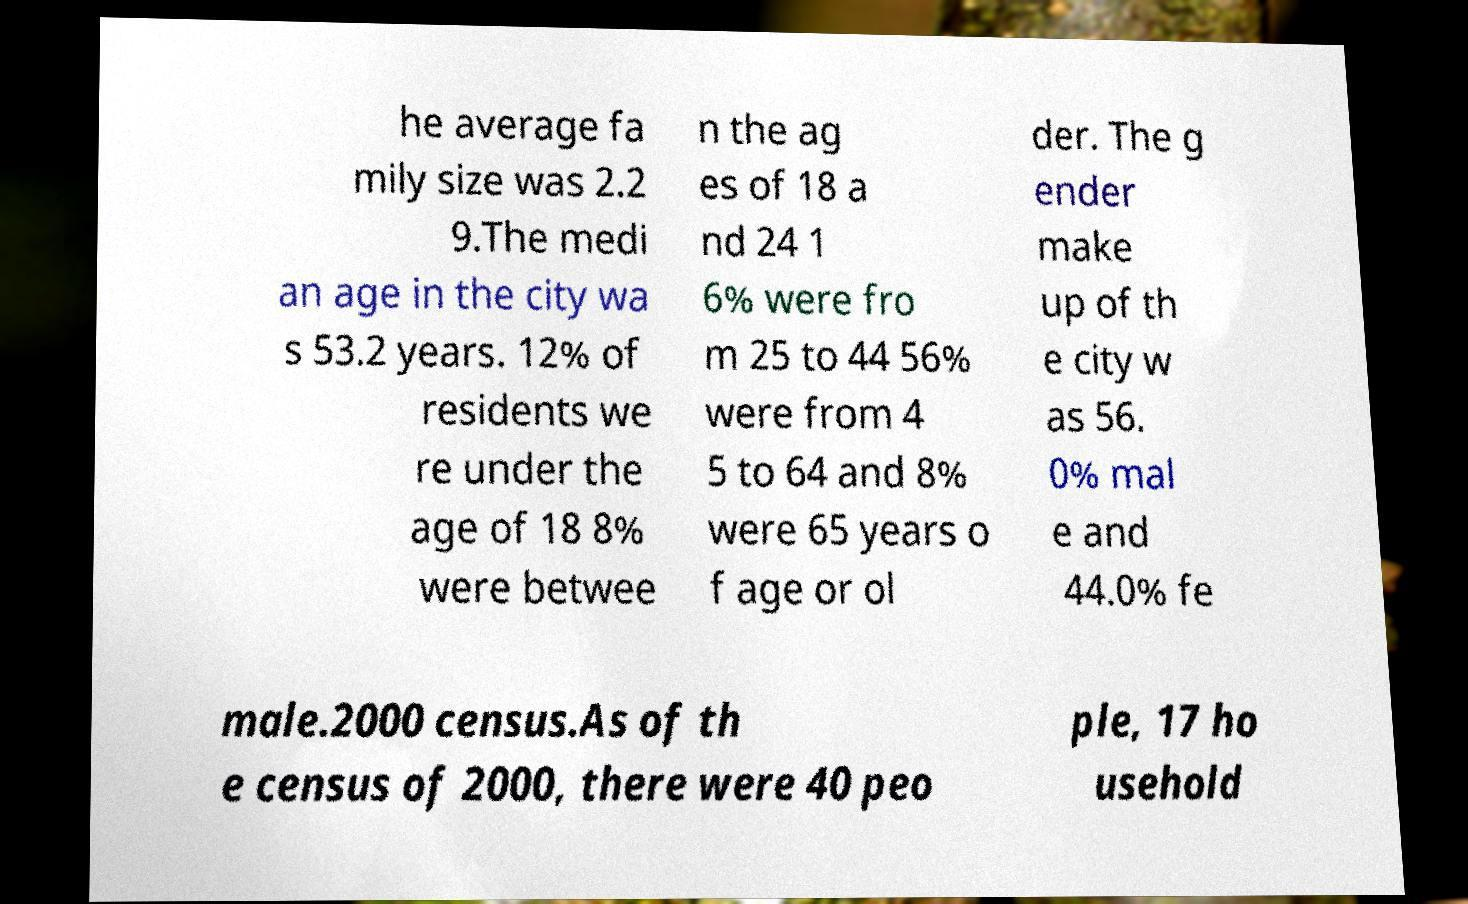Can you accurately transcribe the text from the provided image for me? he average fa mily size was 2.2 9.The medi an age in the city wa s 53.2 years. 12% of residents we re under the age of 18 8% were betwee n the ag es of 18 a nd 24 1 6% were fro m 25 to 44 56% were from 4 5 to 64 and 8% were 65 years o f age or ol der. The g ender make up of th e city w as 56. 0% mal e and 44.0% fe male.2000 census.As of th e census of 2000, there were 40 peo ple, 17 ho usehold 